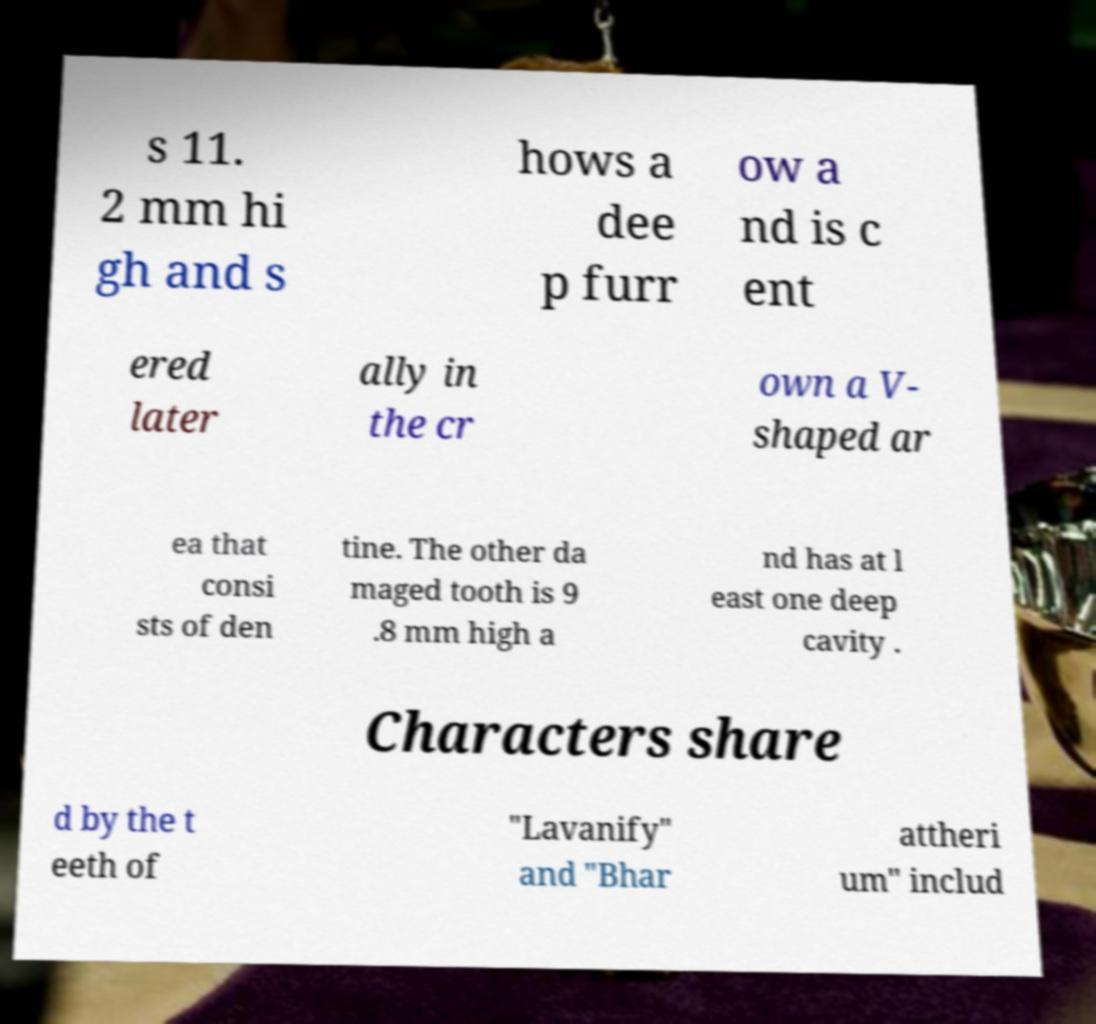Please read and relay the text visible in this image. What does it say? s 11. 2 mm hi gh and s hows a dee p furr ow a nd is c ent ered later ally in the cr own a V- shaped ar ea that consi sts of den tine. The other da maged tooth is 9 .8 mm high a nd has at l east one deep cavity . Characters share d by the t eeth of "Lavanify" and "Bhar attheri um" includ 